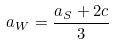<formula> <loc_0><loc_0><loc_500><loc_500>a _ { W } = \frac { a _ { S } + 2 c } { 3 }</formula> 